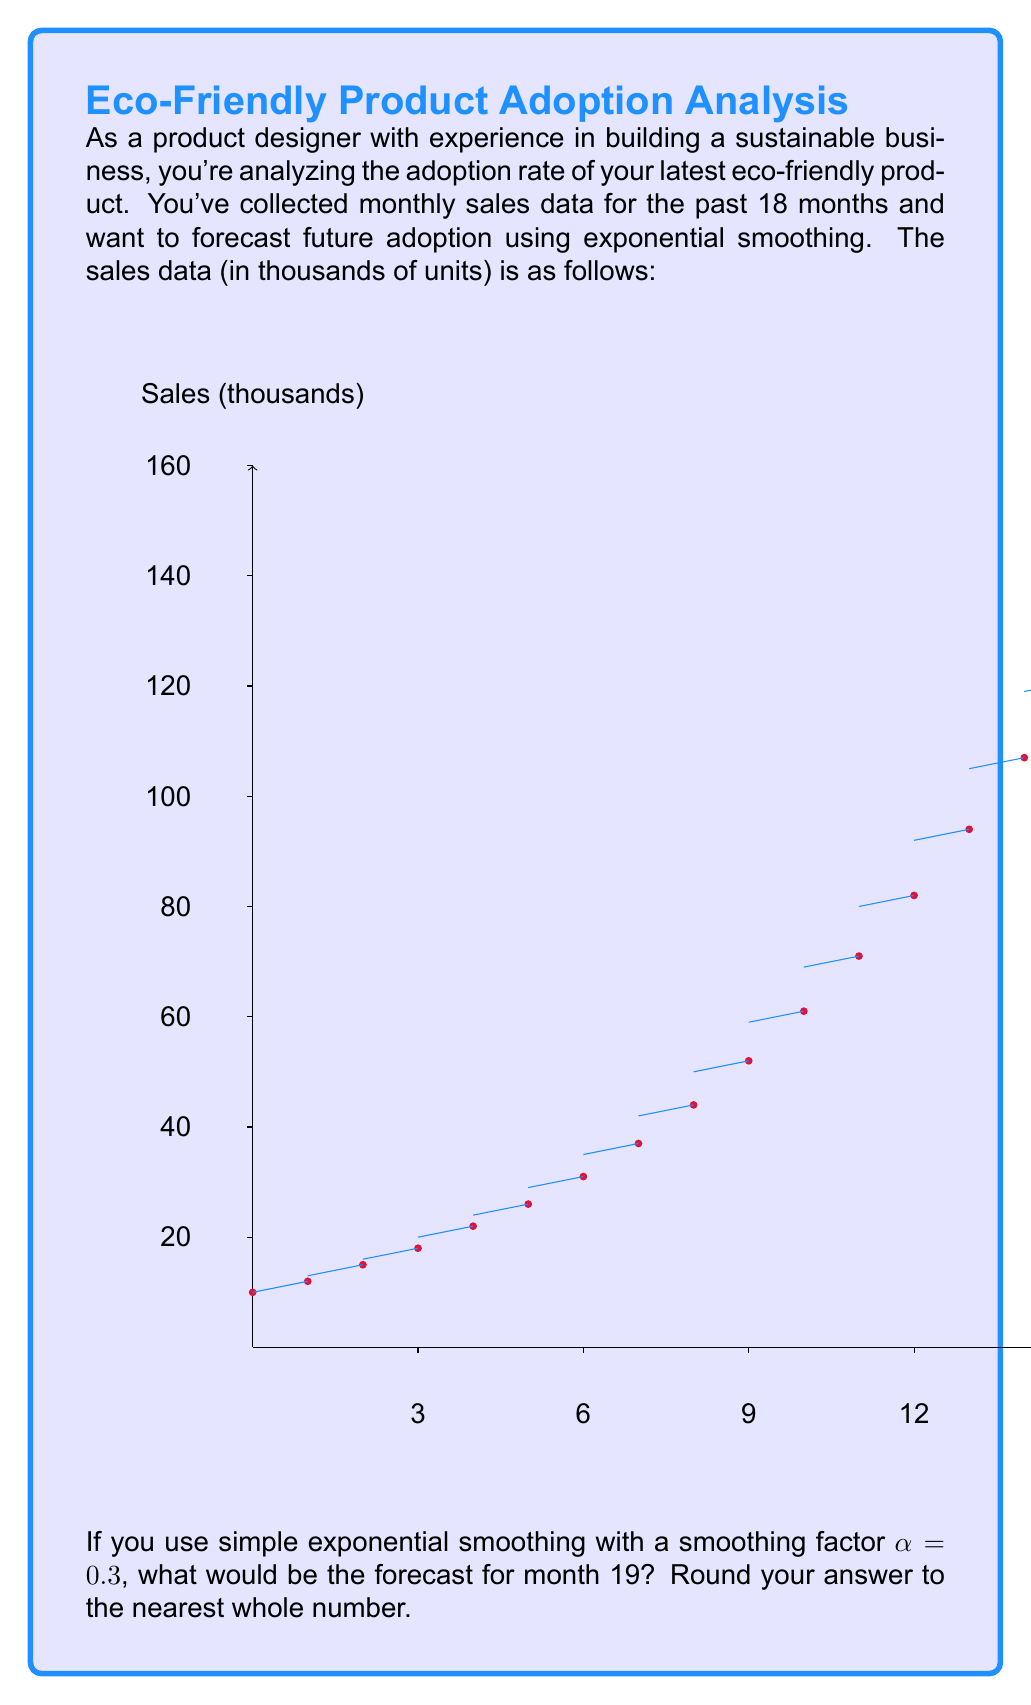What is the answer to this math problem? To solve this problem, we'll use the simple exponential smoothing formula:

$$F_{t+1} = \alpha Y_t + (1-\alpha)F_t$$

Where:
$F_{t+1}$ is the forecast for the next period
$\alpha$ is the smoothing factor (0.3 in this case)
$Y_t$ is the actual value at time t
$F_t$ is the forecast for the current period

We'll start by initializing $F_1$ with the first actual value:

$F_1 = 10$

Then we'll calculate each forecast iteratively:

$F_2 = 0.3(12) + 0.7(10) = 10.6$
$F_3 = 0.3(15) + 0.7(10.6) = 11.92$
...

Continuing this process for all 18 data points:

$F_{18} = 0.3(152) + 0.7(133.48) = 139.04$

Finally, to get the forecast for month 19:

$F_{19} = 0.3(152) + 0.7(139.04) = 142.93$

Rounding to the nearest whole number: 143
Answer: 143 